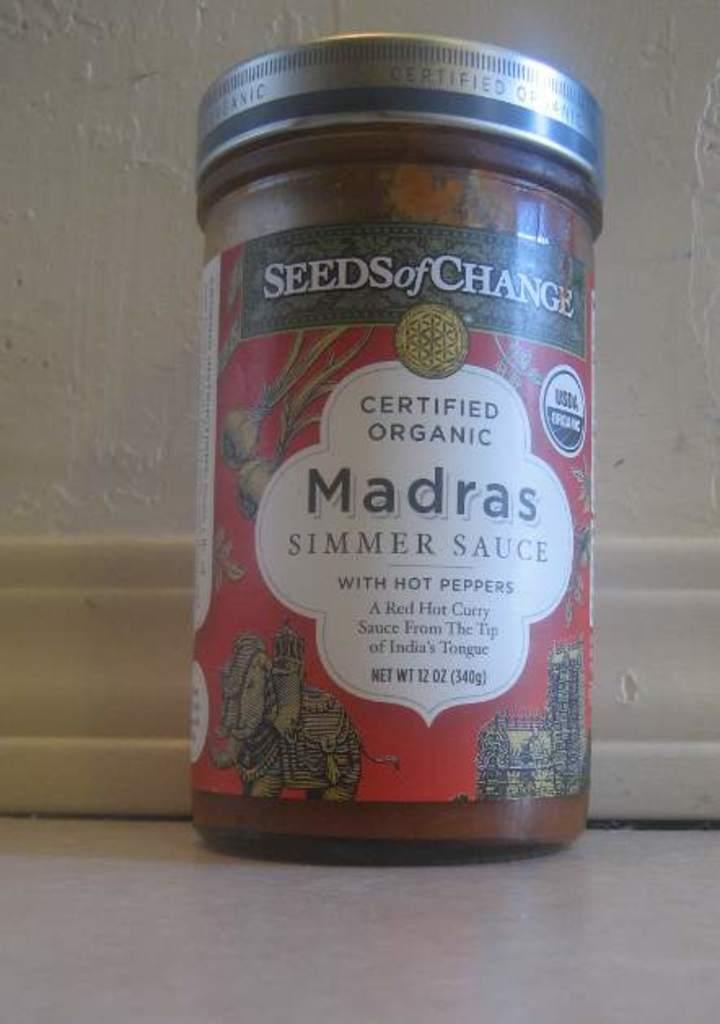What is the main object in the center of the image? There is a small bottle in the center of the image. What type of bottle is it? The bottle is a simmer sauce bottle, as the words "simmer sauce" are written on it. What type of camera is visible in the image? There is no camera present in the image; it only features a small bottle with the words "simmer sauce" on it. 